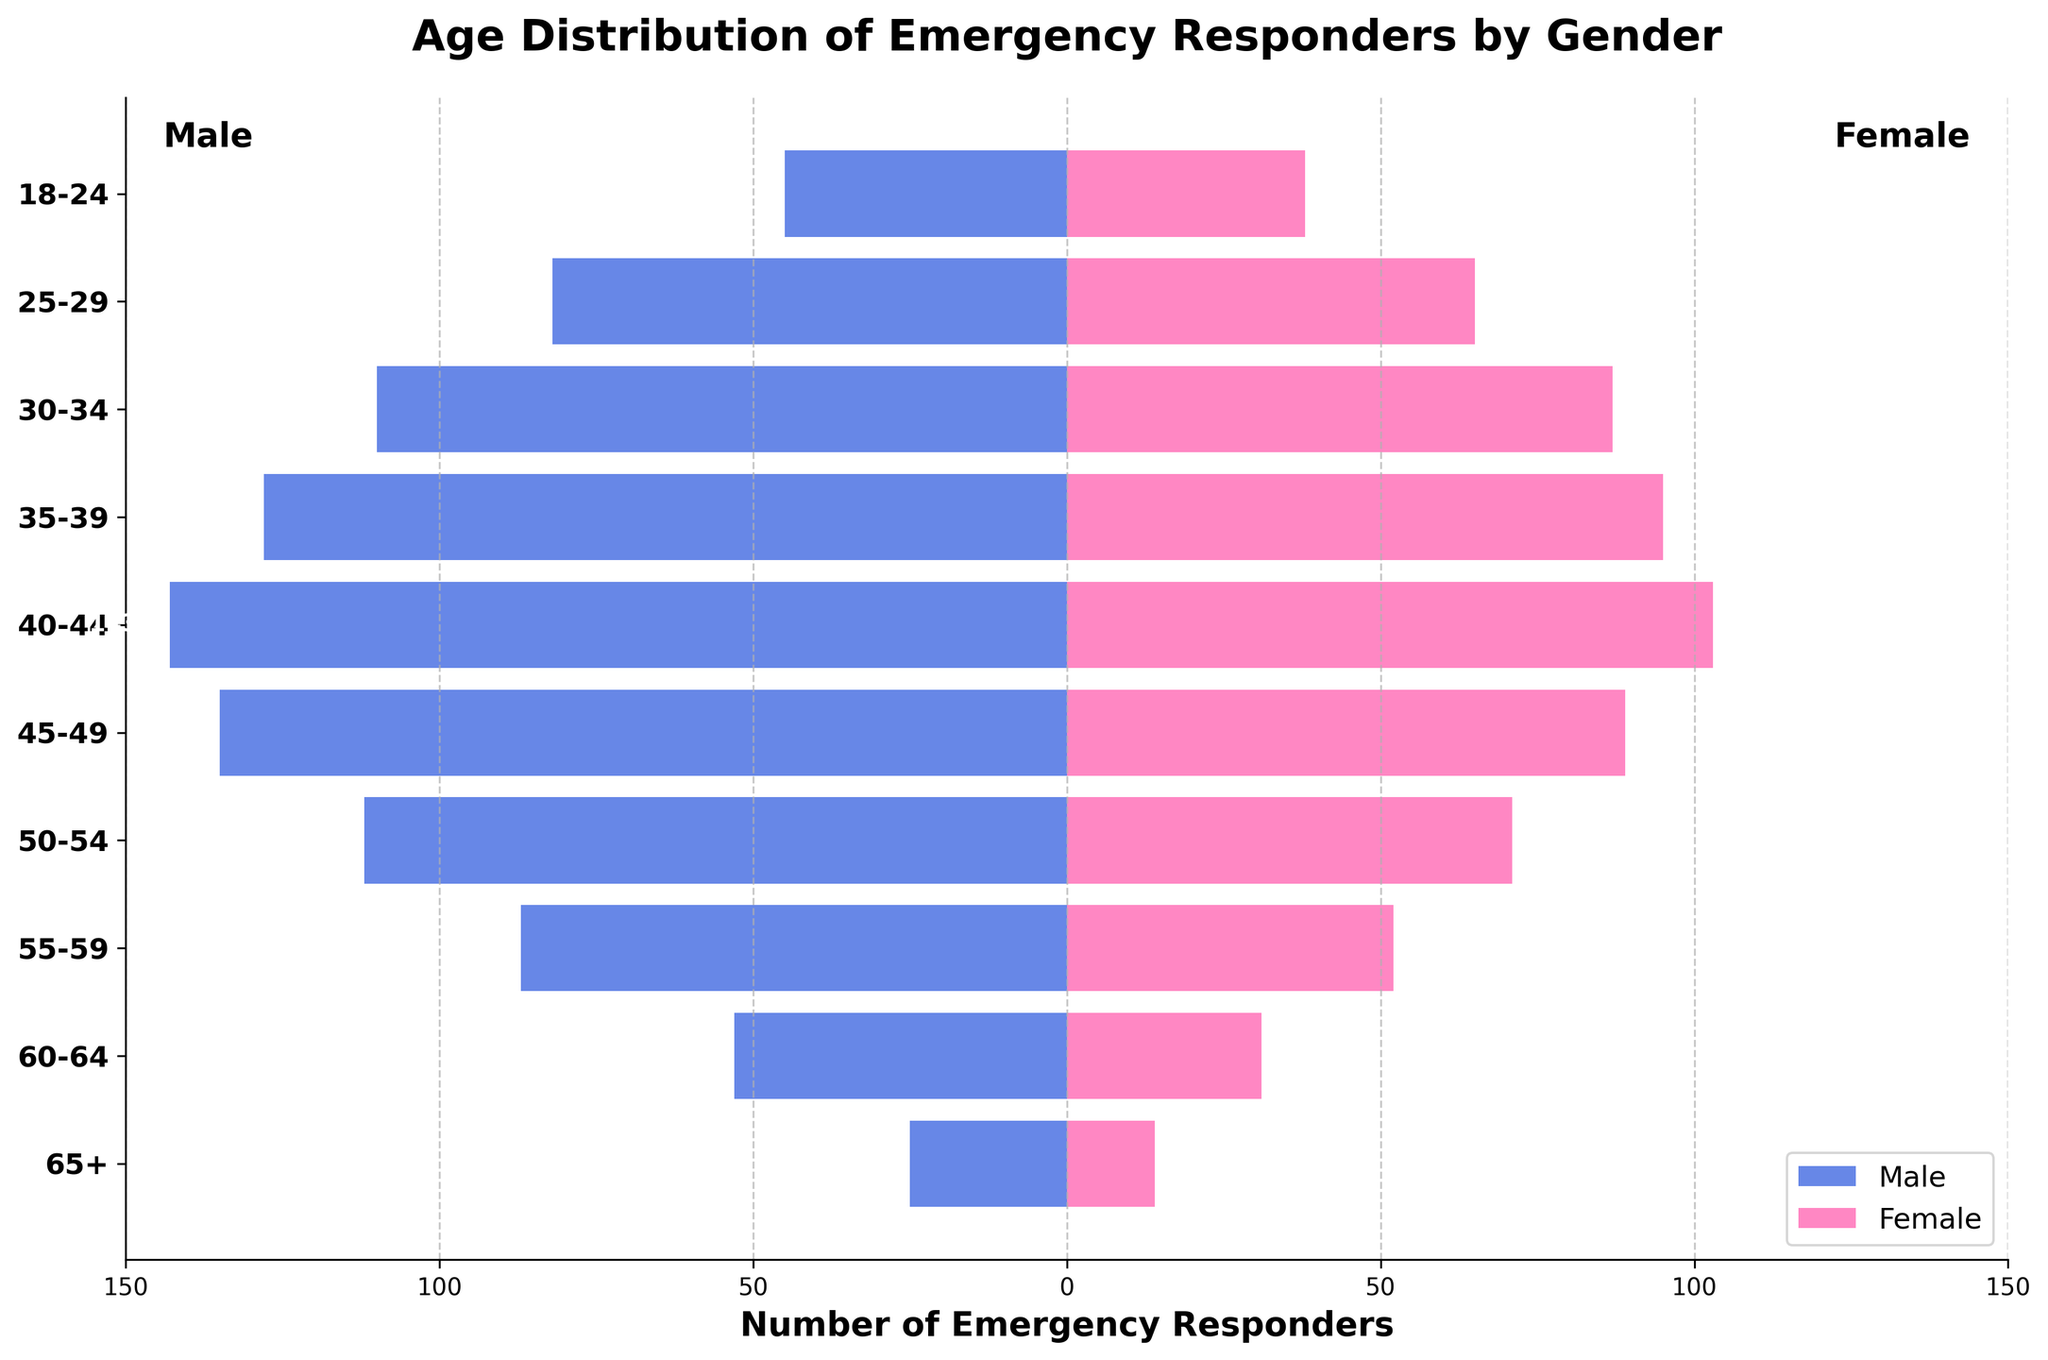What is the title of the figure? The title of the figure is displayed at the top and summarizes the main topic of the visual representation, which is the distribution of emergency responders by age and gender.
Answer: Age Distribution of Emergency Responders by Gender Which gender has more emergency responders in the 35-39 age group? Compare the lengths of the bars for the 35-39 age group. The bar for males is longer, indicating more male emergency responders in this age group.
Answer: Male How many female emergency responders are in the 40-44 age group? Look at the bar corresponding to females in the 40-44 age group. The label at the end of the female bar shows the count.
Answer: 103 Which age group has the fewest male emergency responders? Compare the lengths of the male bars across all age groups. The shortest bar corresponds to the 65+ age group.
Answer: 65+ How many more male emergency responders are there in the 45-49 age group compared to female emergency responders in the same group? Subtract the number of female responders from male responders in the 45-49 age group. 135 - 89 = 46
Answer: 46 In which age group is the difference between male and female emergency responders the smallest? Calculate the difference between male and female emergency responders for each age group and find the smallest difference. The 55-59 age group has the smallest difference (87 males - 52 females = 35).
Answer: 55-59 What is the total number of female emergency responders aged 50 and above? Add the number of female responders in the 50-54, 55-59, 60-64, and 65+ age groups. 71 + 52 + 31 + 14 = 168
Answer: 168 Are there more male or female emergency responders in the 25-29 age group, and by how much? Compare the numbers of male and female responders in the 25-29 age group and find the difference. There are 82 males and 65 females, so there are 17 more males.
Answer: Male by 17 Which age group has the highest number of female emergency responders? Look for the age group with the longest female bar. The 40-44 age group has the longest bar for females.
Answer: 40-44 How does the distribution of emergency responders change as age increases? Analyze the overall trend in bar lengths for both genders as age groups progress from younger to older. Generally, the number of emergency responders decreases as age increases, with a peak in the 40-44 age group and a gradual decline afterward.
Answer: The number decreases with age 